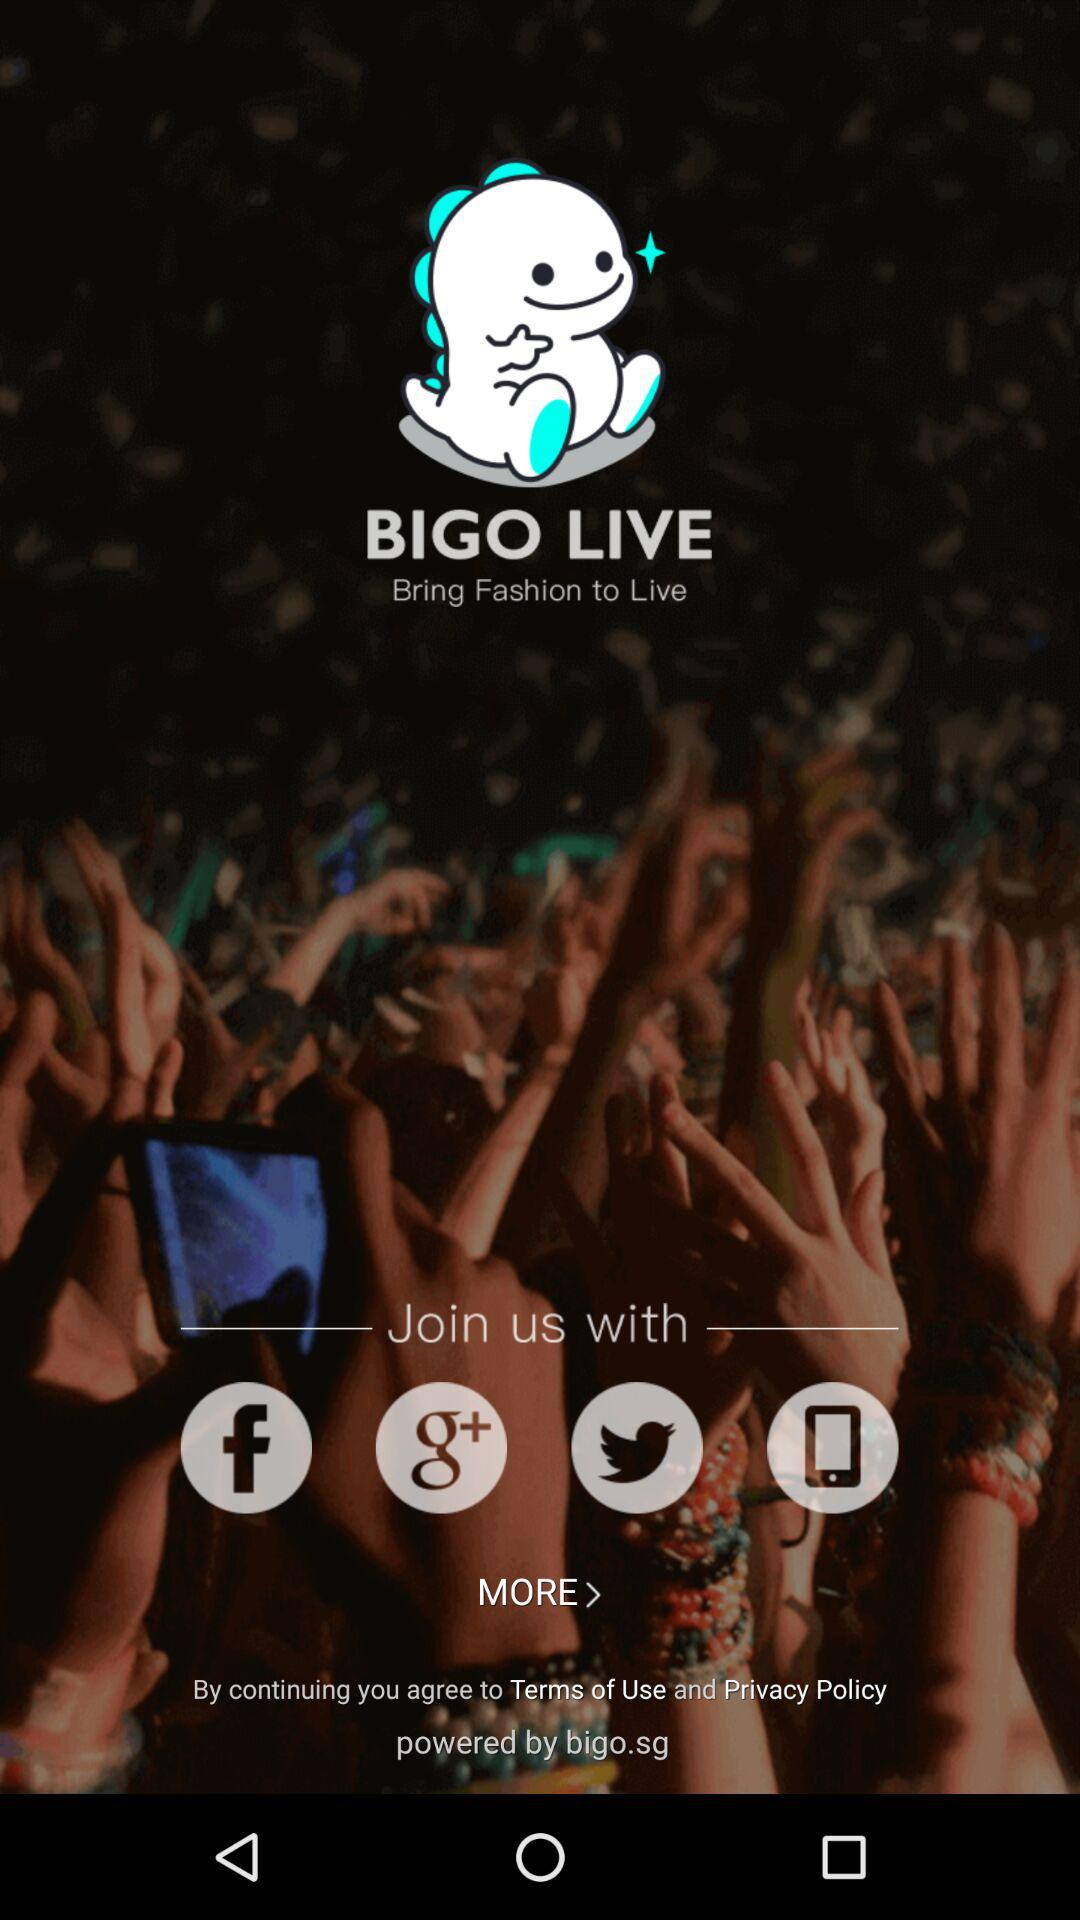Which applications can be used to join? The applications that can be used to join are "Facebook", "Google+" and "Twitter". 